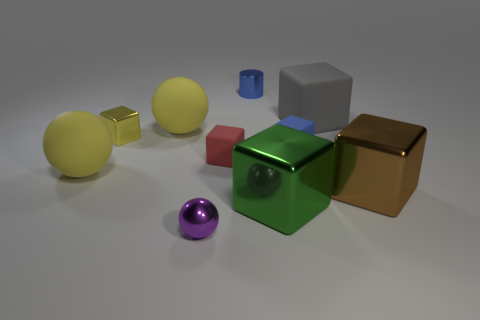Subtract all tiny blue matte blocks. How many blocks are left? 5 Subtract all spheres. How many objects are left? 7 Subtract all blue blocks. How many blocks are left? 5 Subtract all large green blocks. Subtract all small red matte cylinders. How many objects are left? 9 Add 9 red matte blocks. How many red matte blocks are left? 10 Add 5 cyan things. How many cyan things exist? 5 Subtract 0 cyan spheres. How many objects are left? 10 Subtract 1 spheres. How many spheres are left? 2 Subtract all purple cubes. Subtract all gray cylinders. How many cubes are left? 6 Subtract all green cylinders. How many blue cubes are left? 1 